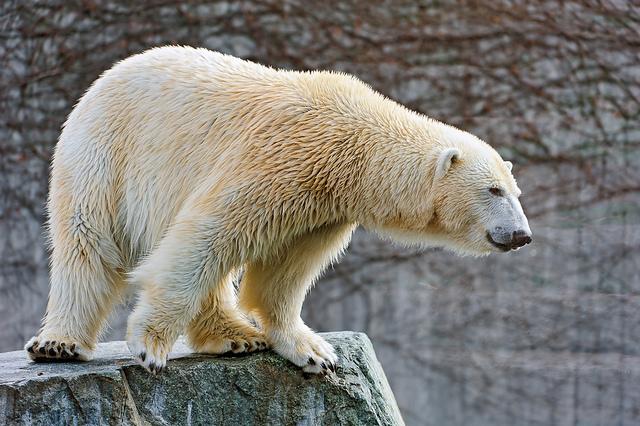Is the bear hibernating?
Answer briefly. No. Is the bear wet or dry?
Keep it brief. Dry. What type of bear is this?
Short answer required. Polar. 